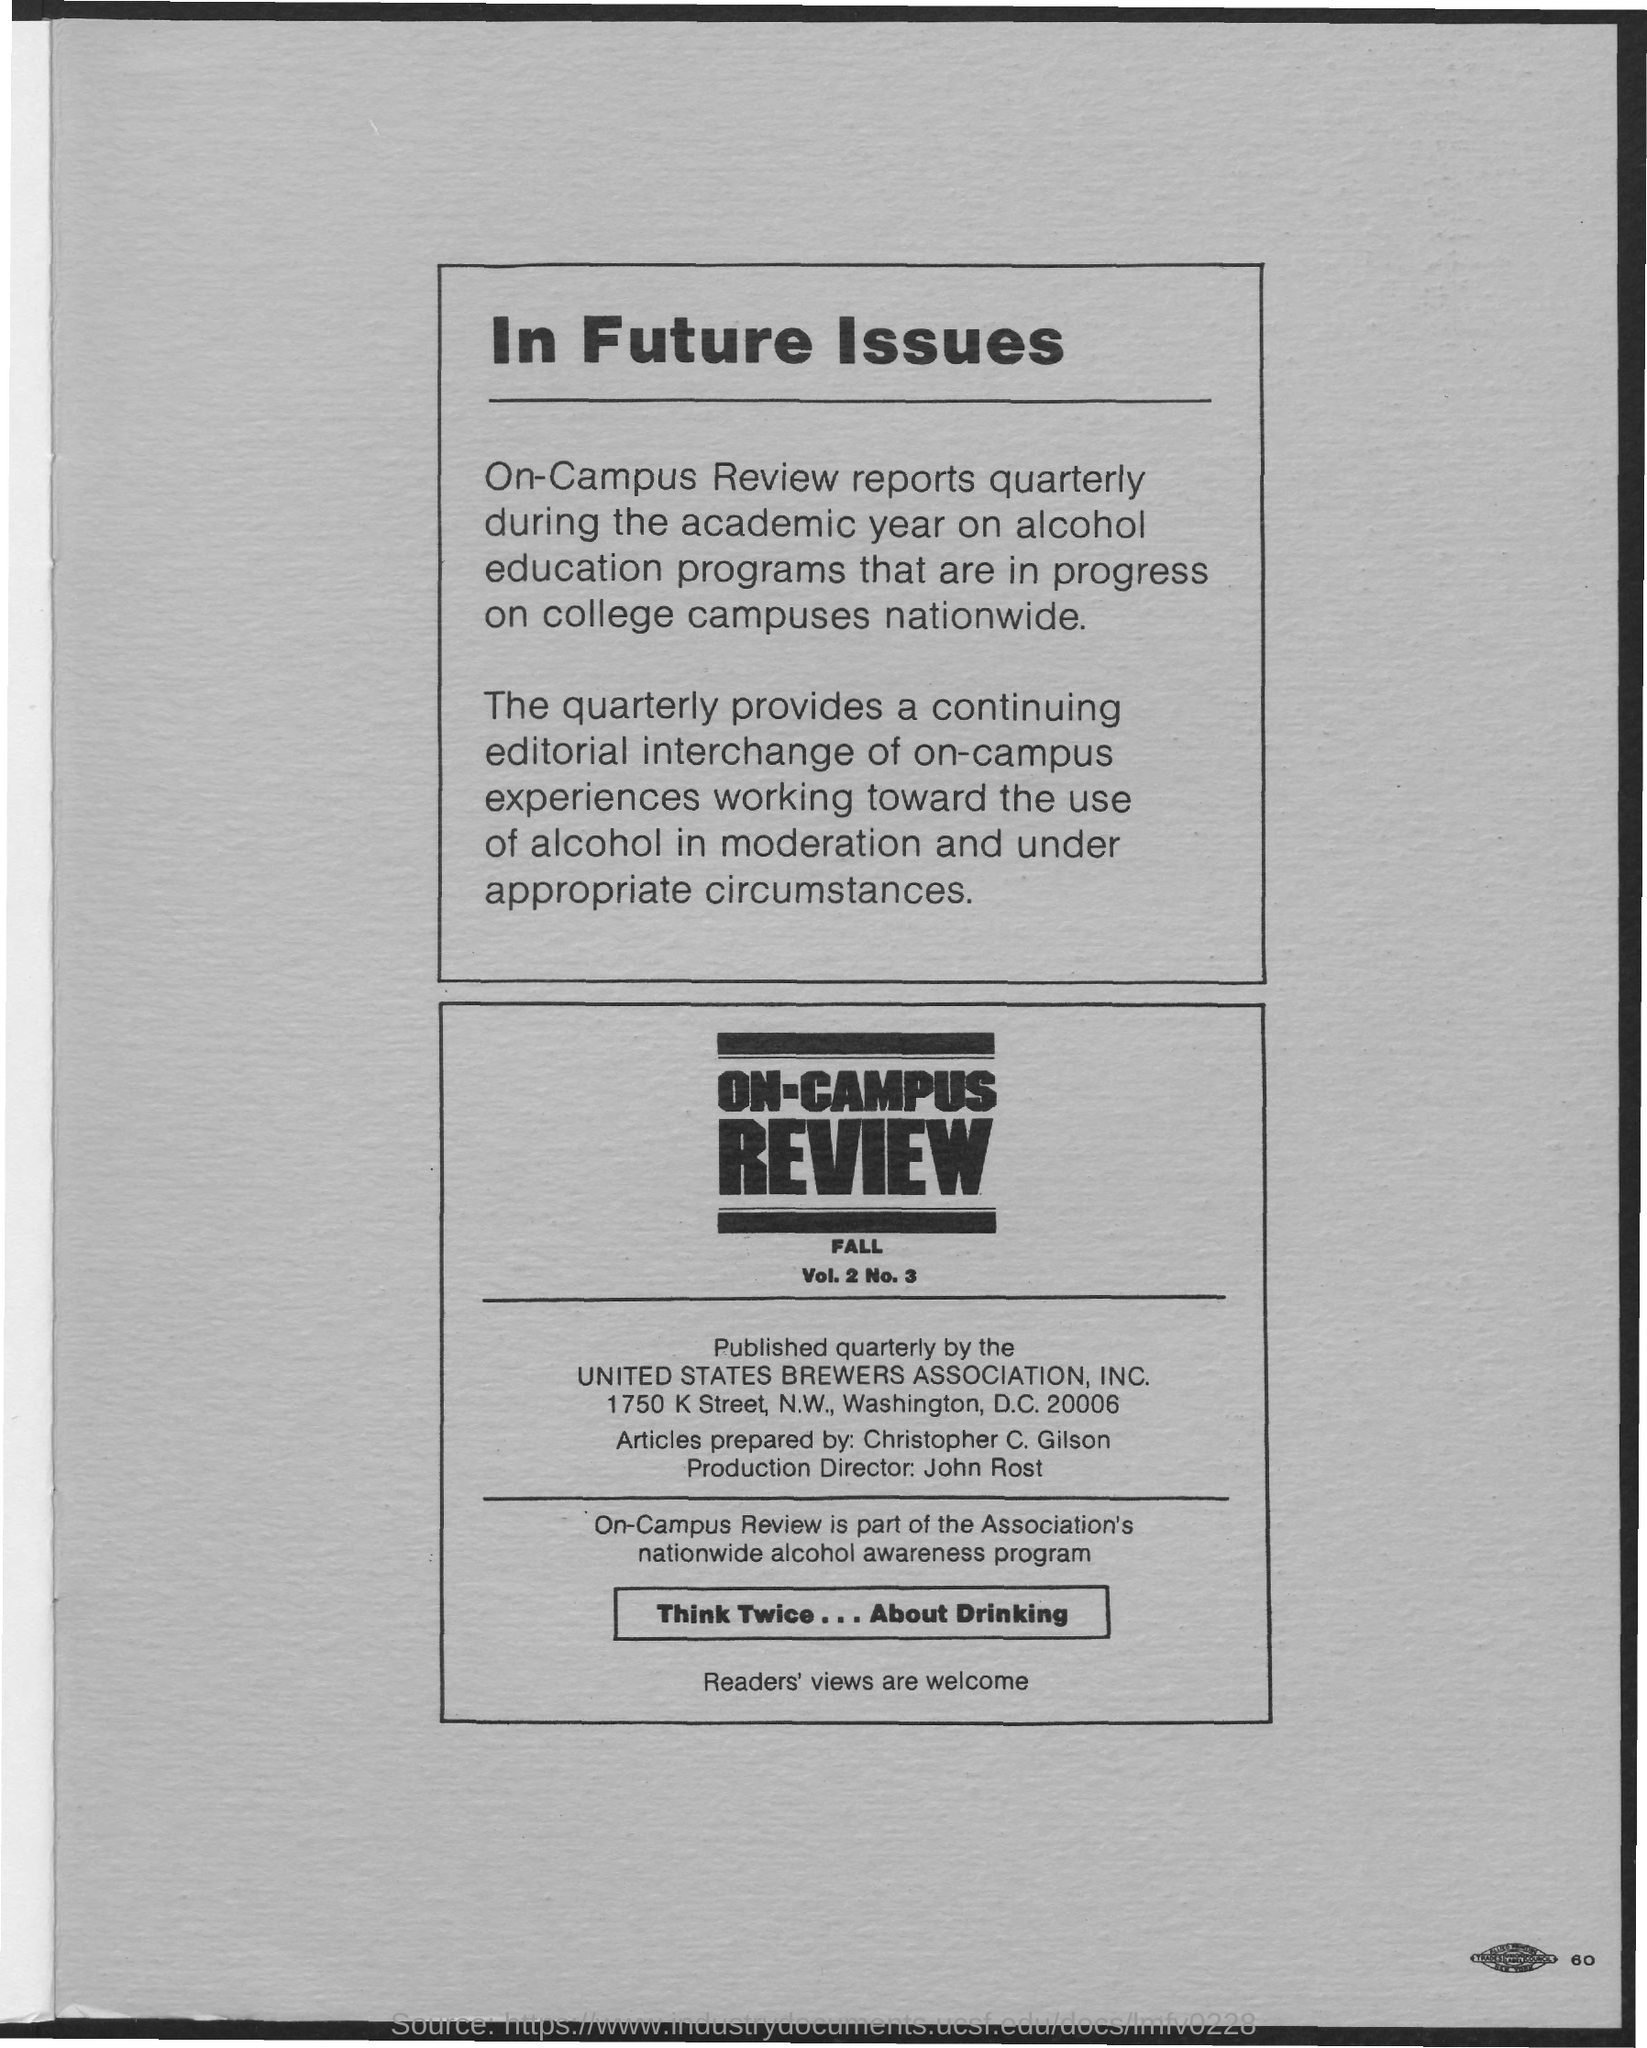Outline some significant characteristics in this image. Christopher C. Gilson is the person who prepares articles. The address of the United States Brewers Association, Inc. is 1750 K street, N.W., Washington, D.C. 20006. The production director's name is John Rost. On-Campus Review is a quarterly publication produced by the United States Brewers Association, Inc. 